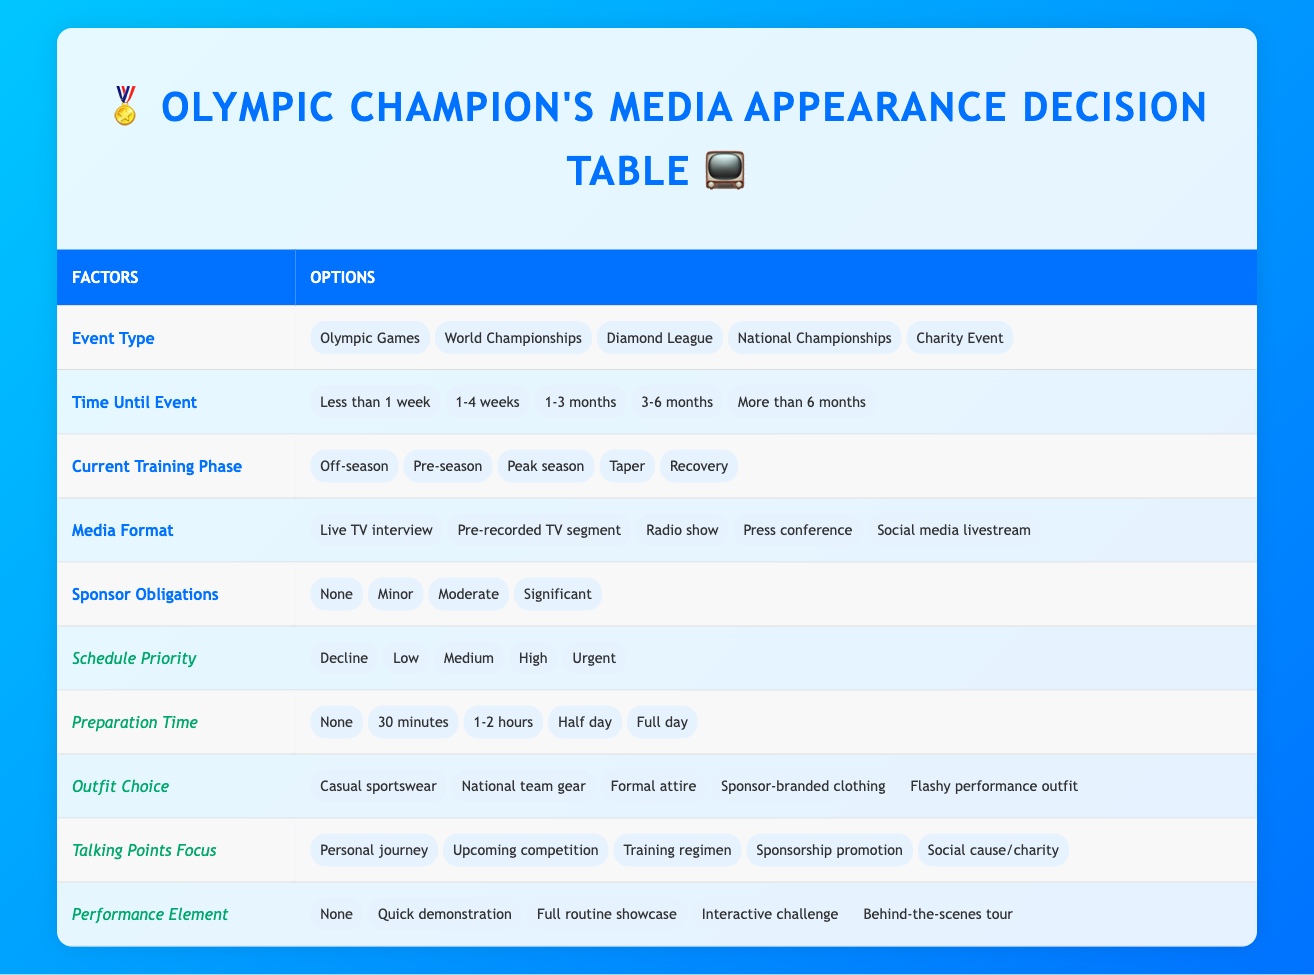What is the highest Schedule Priority option available? The options for Schedule Priority include Decline, Low, Medium, High, and Urgent. The highest option is Urgent.
Answer: Urgent What types of Event Types are available in the table? The table lists five Event Types: Olympic Games, World Championships, Diamond League, National Championships, and Charity Event.
Answer: Olympic Games, World Championships, Diamond League, National Championships, Charity Event Is there any preparation time required for an Urgent media appearance? The table indicates that for Urgent schedule priority, the preparation time can be None, 30 minutes, 1-2 hours, Half day, or Full day. Thus, it is possible to have an Urgent media appearance with no preparation time required.
Answer: Yes If the Current Training Phase is "Peak season," what are the possible Schedule Priority options? Referring to the table, it states that regardless of the Current Training Phase, the Schedule Priority options remain the same: Decline, Low, Medium, High, and Urgent. Therefore, all Schedule Priority options are available in Peak season.
Answer: All options are possible Which Media Format would allow for audience interaction? The Media Format options include Live TV interview, Pre-recorded TV segment, Radio show, Press conference, and Social media livestream. The Social media livestream format is inherently interactive, allowing for real-time audience participation.
Answer: Social media livestream If there are Significant sponsor obligations, what may be a good Outfit Choice? Sponsor obligations include None, Minor, Moderate, and Significant. Significant obligations would likely require a choice that aligns closely with sponsors. Sponsor-branded clothing would be appropriate in this context.
Answer: Sponsor-branded clothing If you have to decline a media appearance, what does that indicate about your Schedule Priority? The Schedule Priority options include Decline, which directly implies that you are choosing not to participate in the media appearance, indicating other commitments or preferences take precedence.
Answer: You are prioritizing other commitments What would be the ideal Talking Points Focus if the event is a Charity Event? For a Charity Event, the most relevant Talking Points Focus would be Social cause/charity, as this aligns best with the event's purpose and audience engagement.
Answer: Social cause/charity If you have a Full day available for preparation, how does that affect your Schedule Priority? A Full day of preparation allows for higher quality in the media appearance, potentially leading to a higher Schedule Priority designation. While it does not guarantee a higher priority, it does provide freedom to prepare thoroughly.
Answer: It could lead to a higher priority 